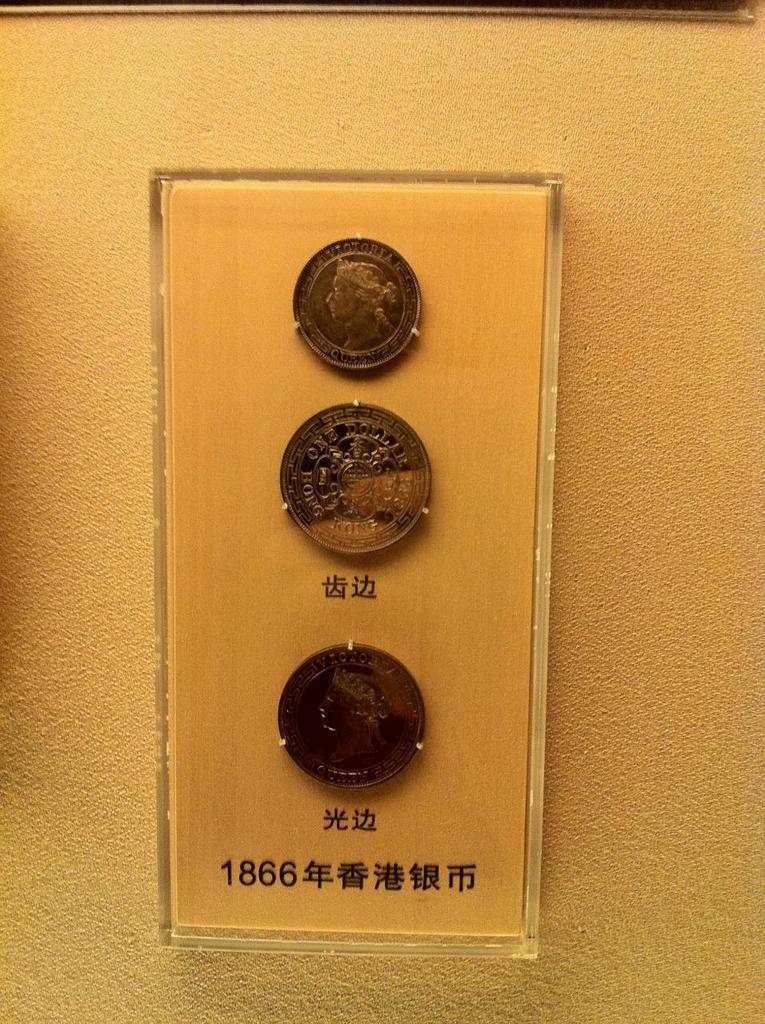What queen is on the top coin?
Make the answer very short. Victoria. 